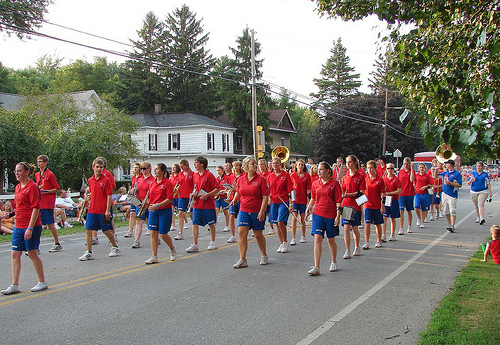<image>
Is there a human under the telephone pole? No. The human is not positioned under the telephone pole. The vertical relationship between these objects is different. Is the girl behind the tree? No. The girl is not behind the tree. From this viewpoint, the girl appears to be positioned elsewhere in the scene. 